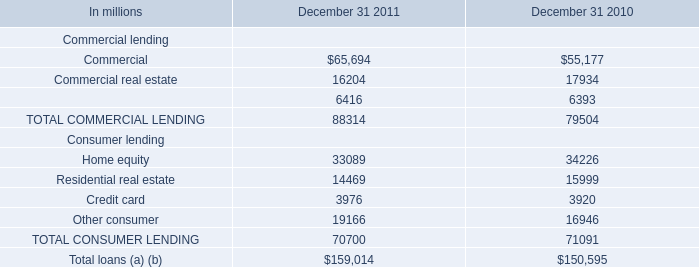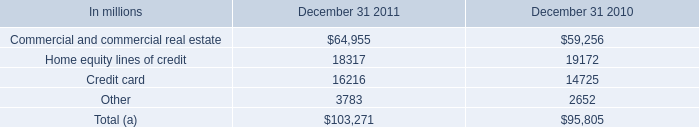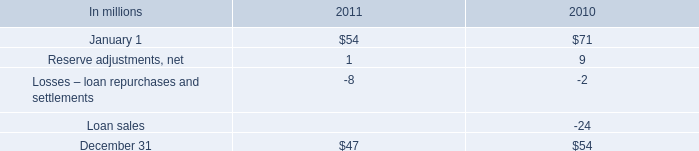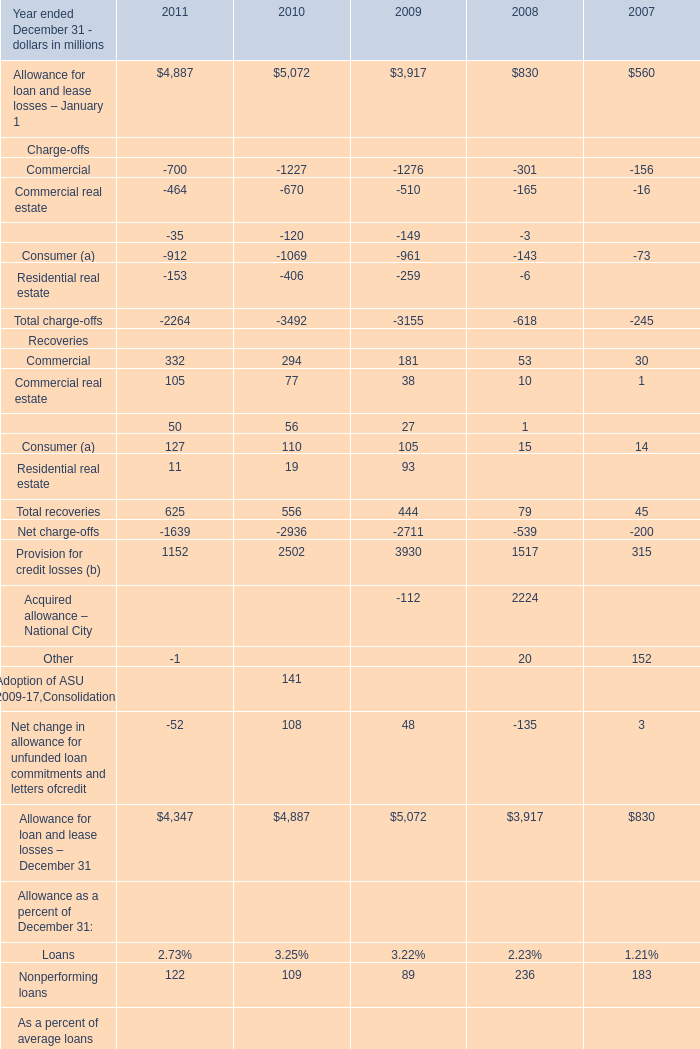Which year ended December 31 is Total recoveries the highest? 
Answer: 2011. 